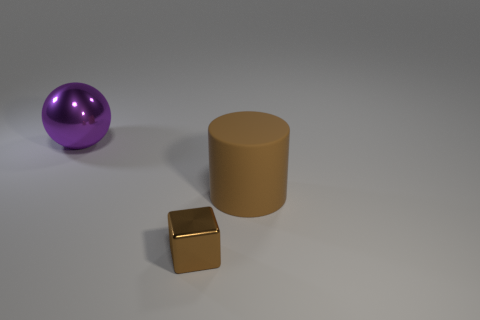What number of red things are large spheres or small shiny cubes?
Offer a very short reply. 0. Is there a cyan matte cube that has the same size as the brown metallic object?
Ensure brevity in your answer.  No. What number of cyan blocks are there?
Keep it short and to the point. 0. What number of big objects are balls or brown metallic cubes?
Offer a terse response. 1. The object that is right of the thing in front of the big thing that is to the right of the purple thing is what color?
Provide a short and direct response. Brown. What number of other things are there of the same color as the large rubber object?
Offer a terse response. 1. How many rubber objects are tiny gray cylinders or purple spheres?
Provide a short and direct response. 0. Do the big object that is to the right of the metal block and the metal object in front of the big brown rubber cylinder have the same color?
Your answer should be compact. Yes. Are there any other things that are the same material as the cylinder?
Offer a very short reply. No. Are there more cylinders on the right side of the small brown cube than brown matte blocks?
Your response must be concise. Yes. 